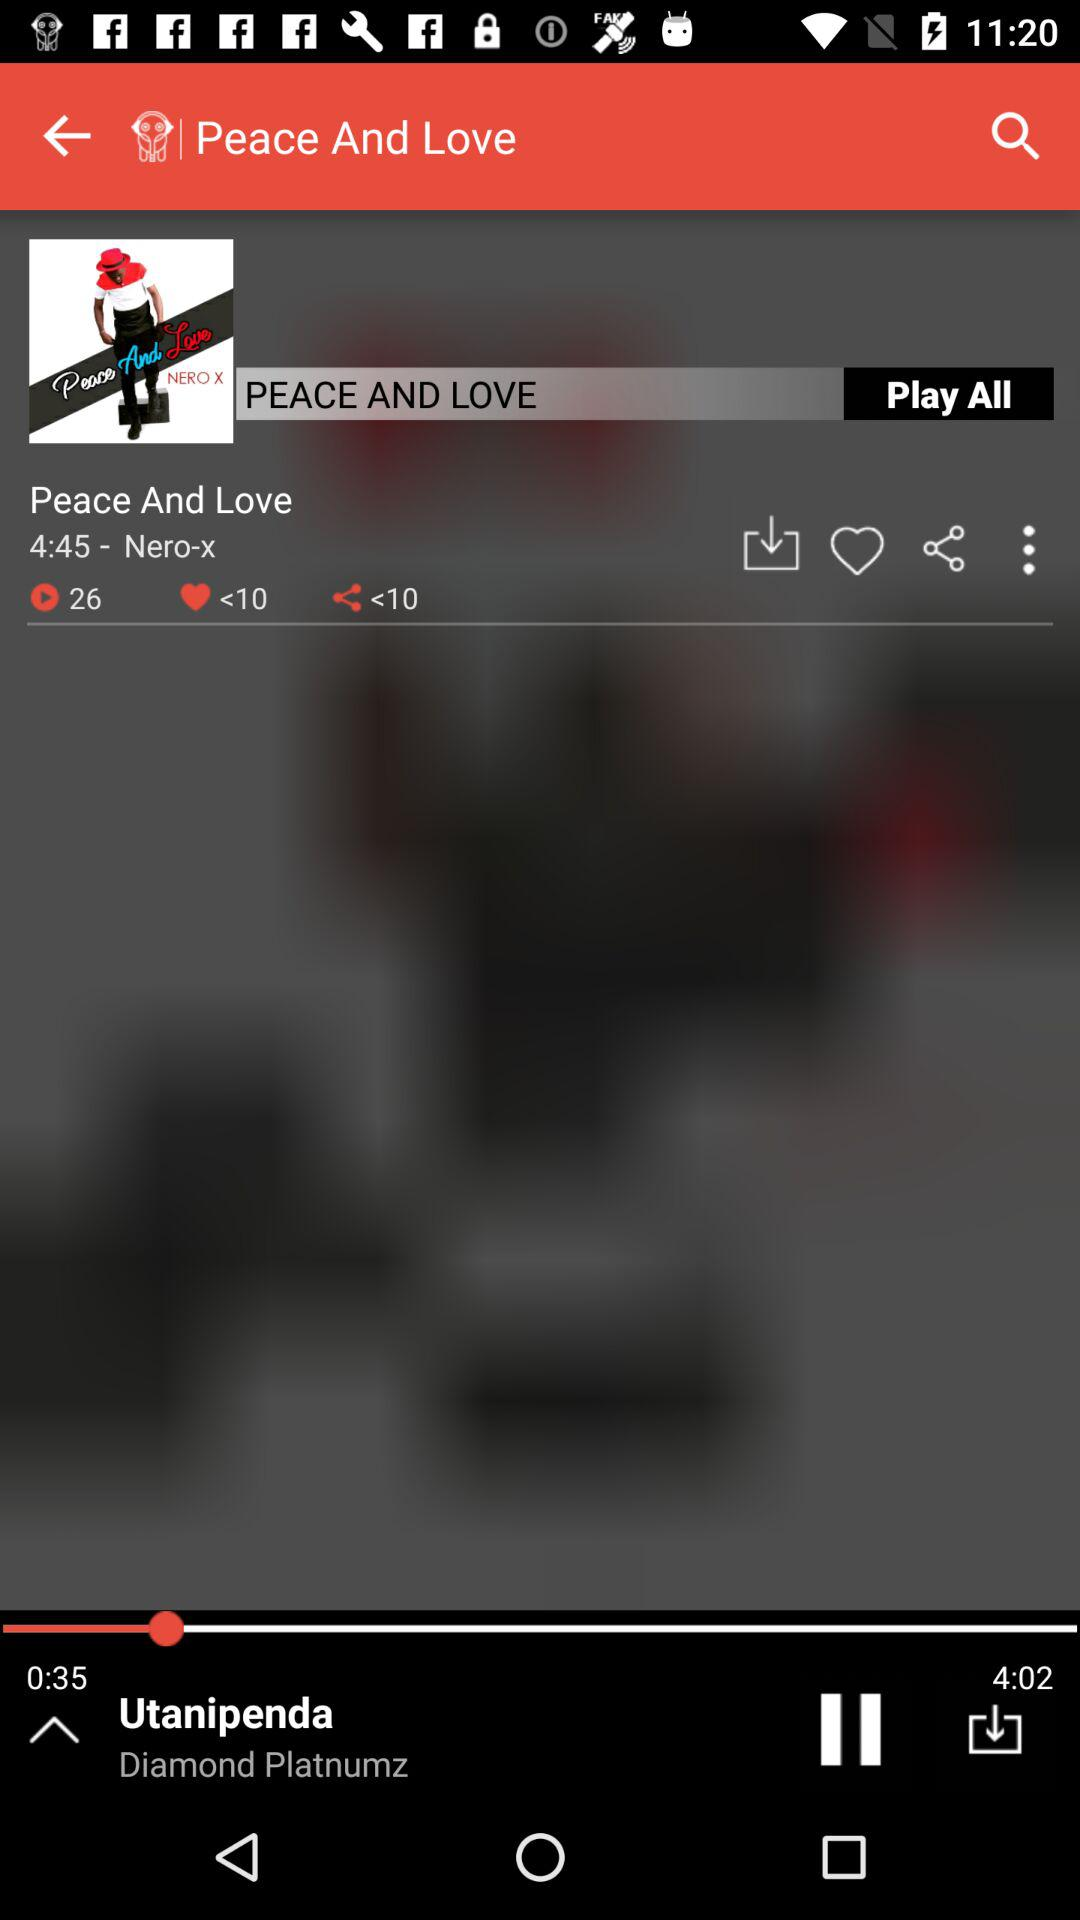What is the name of the album? The name of the album is "Peace And Love". 